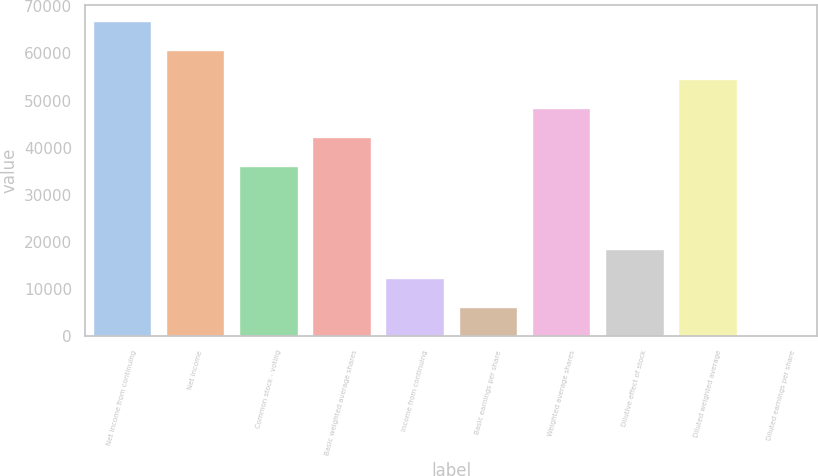Convert chart. <chart><loc_0><loc_0><loc_500><loc_500><bar_chart><fcel>Net income from continuing<fcel>Net income<fcel>Common stock - voting<fcel>Basic weighted average shares<fcel>Income from continuing<fcel>Basic earnings per share<fcel>Weighted average shares<fcel>Dilutive effect of stock<fcel>Diluted weighted average<fcel>Diluted earnings per share<nl><fcel>66992.2<fcel>60814<fcel>36101<fcel>42279.2<fcel>12358.1<fcel>6179.83<fcel>48457.5<fcel>18536.3<fcel>54635.7<fcel>1.59<nl></chart> 